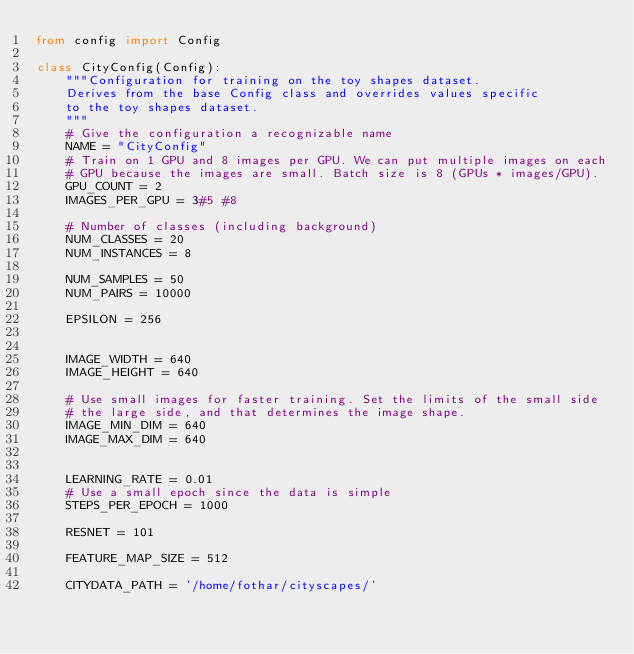Convert code to text. <code><loc_0><loc_0><loc_500><loc_500><_Python_>from config import Config

class CityConfig(Config):
    """Configuration for training on the toy shapes dataset.
    Derives from the base Config class and overrides values specific
    to the toy shapes dataset.
    """
    # Give the configuration a recognizable name
    NAME = "CityConfig"
    # Train on 1 GPU and 8 images per GPU. We can put multiple images on each
    # GPU because the images are small. Batch size is 8 (GPUs * images/GPU).
    GPU_COUNT = 2
    IMAGES_PER_GPU = 3#5 #8

    # Number of classes (including background)
    NUM_CLASSES = 20
    NUM_INSTANCES = 8

    NUM_SAMPLES = 50
    NUM_PAIRS = 10000

    EPSILON = 256


    IMAGE_WIDTH = 640
    IMAGE_HEIGHT = 640

    # Use small images for faster training. Set the limits of the small side
    # the large side, and that determines the image shape.
    IMAGE_MIN_DIM = 640
    IMAGE_MAX_DIM = 640
  

    LEARNING_RATE = 0.01
    # Use a small epoch since the data is simple
    STEPS_PER_EPOCH = 1000

    RESNET = 101

    FEATURE_MAP_SIZE = 512

    CITYDATA_PATH = '/home/fothar/cityscapes/'

</code> 